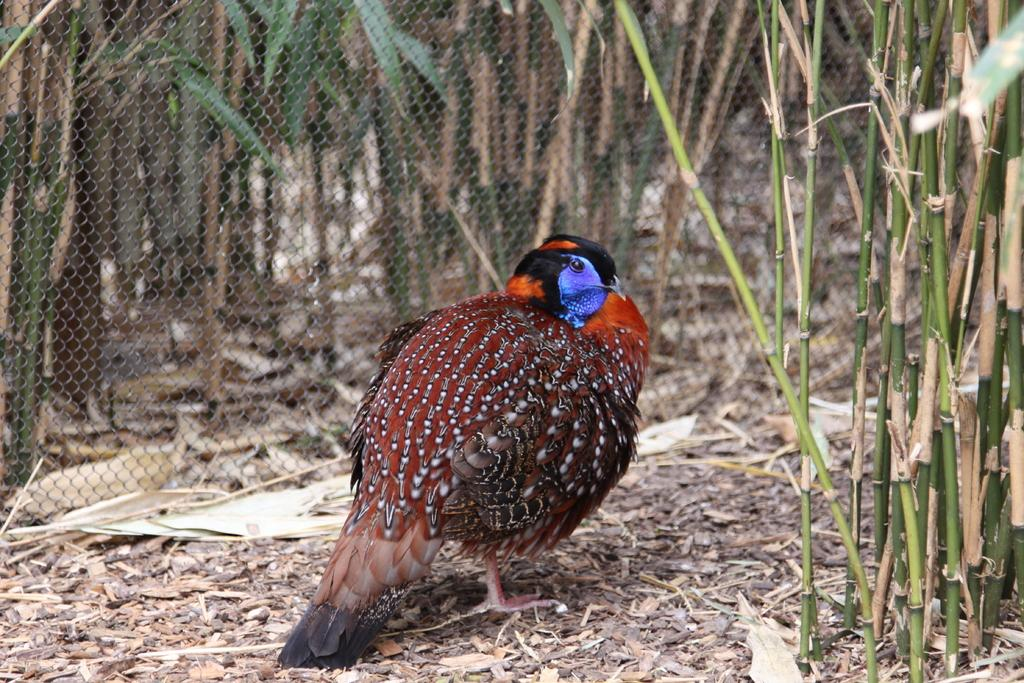What type of animal can be seen in the image? There is a colorful bird in the image. What can be seen in the background of the image? There is a fence and trees in the background of the image. How many people are in the crowd surrounding the bird in the image? There is no crowd present in the image; it only features a colorful bird and background elements. 